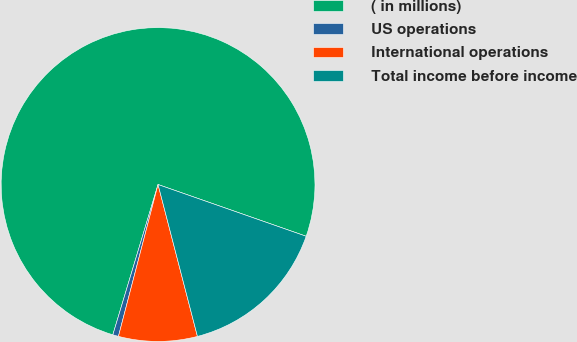Convert chart. <chart><loc_0><loc_0><loc_500><loc_500><pie_chart><fcel>( in millions)<fcel>US operations<fcel>International operations<fcel>Total income before income<nl><fcel>75.69%<fcel>0.59%<fcel>8.1%<fcel>15.61%<nl></chart> 